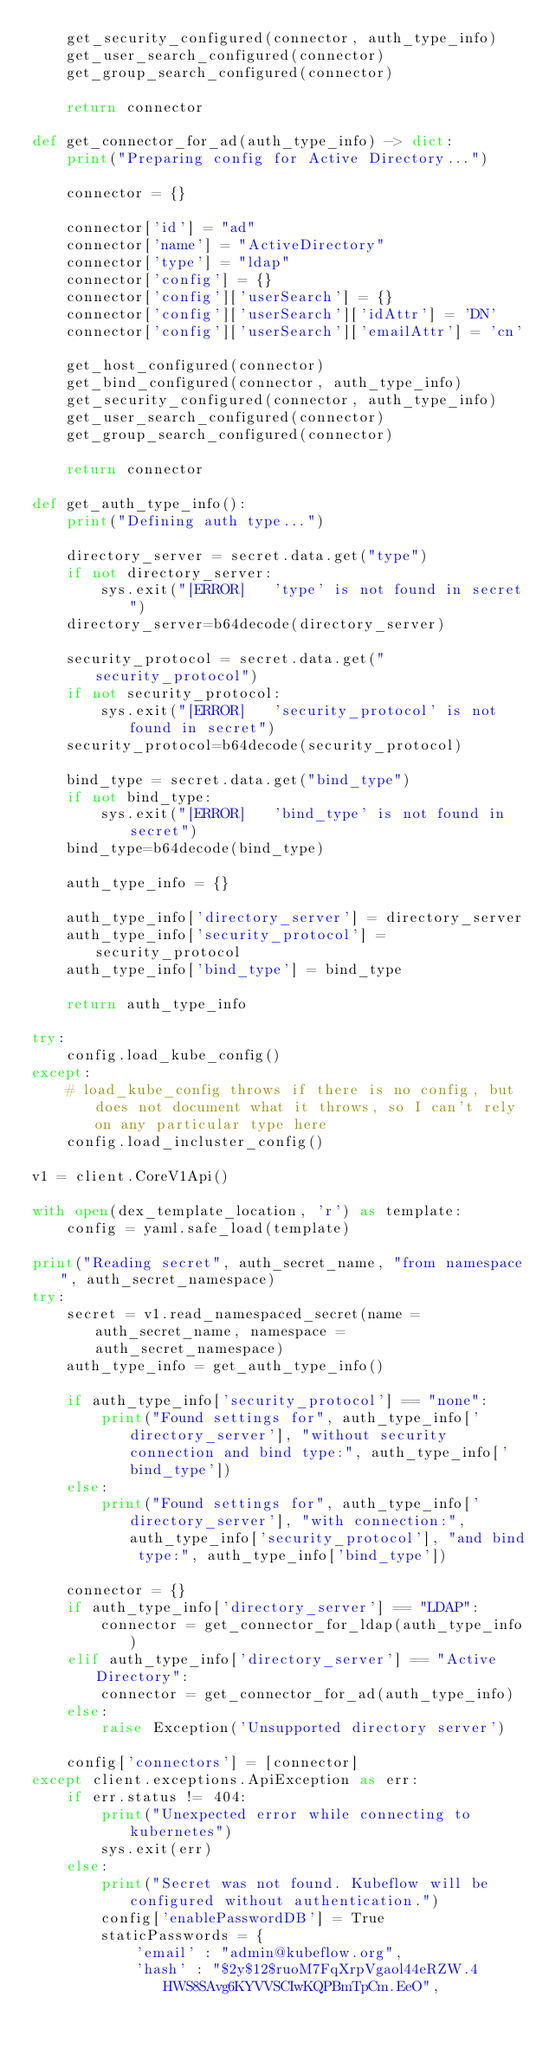Convert code to text. <code><loc_0><loc_0><loc_500><loc_500><_Python_>    get_security_configured(connector, auth_type_info)
    get_user_search_configured(connector)
    get_group_search_configured(connector)

    return connector

def get_connector_for_ad(auth_type_info) -> dict:
    print("Preparing config for Active Directory...")

    connector = {}
    
    connector['id'] = "ad"
    connector['name'] = "ActiveDirectory"
    connector['type'] = "ldap"
    connector['config'] = {}
    connector['config']['userSearch'] = {}
    connector['config']['userSearch']['idAttr'] = 'DN'
    connector['config']['userSearch']['emailAttr'] = 'cn'

    get_host_configured(connector)
    get_bind_configured(connector, auth_type_info)
    get_security_configured(connector, auth_type_info)
    get_user_search_configured(connector)
    get_group_search_configured(connector)

    return connector

def get_auth_type_info():
    print("Defining auth type...")

    directory_server = secret.data.get("type")
    if not directory_server:
        sys.exit("[ERROR]   'type' is not found in secret")
    directory_server=b64decode(directory_server)

    security_protocol = secret.data.get("security_protocol")
    if not security_protocol:
        sys.exit("[ERROR]   'security_protocol' is not found in secret")
    security_protocol=b64decode(security_protocol)

    bind_type = secret.data.get("bind_type")
    if not bind_type:
        sys.exit("[ERROR]   'bind_type' is not found in secret")
    bind_type=b64decode(bind_type)
    
    auth_type_info = {}
    
    auth_type_info['directory_server'] = directory_server
    auth_type_info['security_protocol'] = security_protocol
    auth_type_info['bind_type'] = bind_type

    return auth_type_info

try:
    config.load_kube_config()
except:
    # load_kube_config throws if there is no config, but does not document what it throws, so I can't rely on any particular type here
    config.load_incluster_config()

v1 = client.CoreV1Api()

with open(dex_template_location, 'r') as template:
    config = yaml.safe_load(template)

print("Reading secret", auth_secret_name, "from namespace", auth_secret_namespace)
try:
    secret = v1.read_namespaced_secret(name = auth_secret_name, namespace = auth_secret_namespace)
    auth_type_info = get_auth_type_info()

    if auth_type_info['security_protocol'] == "none":
        print("Found settings for", auth_type_info['directory_server'], "without security connection and bind type:", auth_type_info['bind_type'])
    else:
        print("Found settings for", auth_type_info['directory_server'], "with connection:", auth_type_info['security_protocol'], "and bind type:", auth_type_info['bind_type'])

    connector = {}
    if auth_type_info['directory_server'] == "LDAP":
        connector = get_connector_for_ldap(auth_type_info)
    elif auth_type_info['directory_server'] == "Active Directory":
        connector = get_connector_for_ad(auth_type_info)
    else:
        raise Exception('Unsupported directory server')

    config['connectors'] = [connector]
except client.exceptions.ApiException as err:
    if err.status != 404:
        print("Unexpected error while connecting to kubernetes")
        sys.exit(err)
    else:
        print("Secret was not found. Kubeflow will be configured without authentication.")
        config['enablePasswordDB'] = True
        staticPasswords = {
            'email' : "admin@kubeflow.org",
            'hash' : "$2y$12$ruoM7FqXrpVgaol44eRZW.4HWS8SAvg6KYVVSCIwKQPBmTpCm.EeO",</code> 